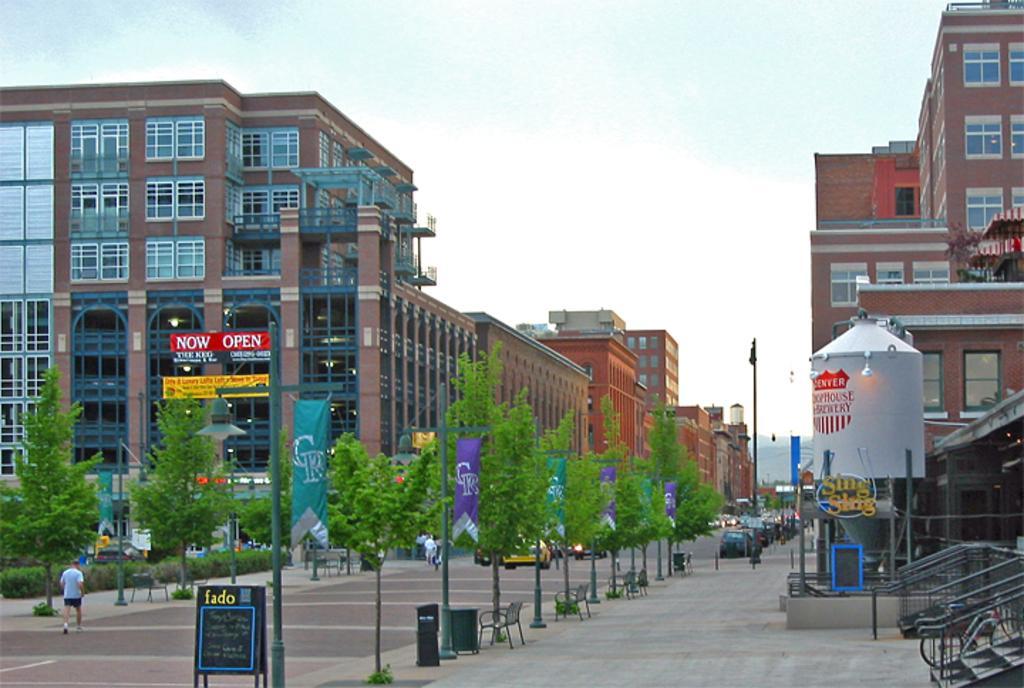How would you summarize this image in a sentence or two? In this image we can see buildings, stairs, benches, trees, poles, people, banners, boards and vehicles on the road. At the top of the image, we can see the sky. On the right side of the image, we can see a metal object. 